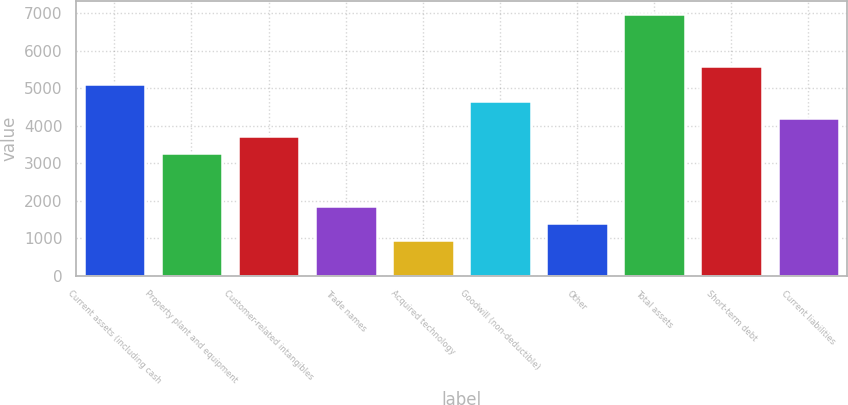<chart> <loc_0><loc_0><loc_500><loc_500><bar_chart><fcel>Current assets (including cash<fcel>Property plant and equipment<fcel>Customer-related intangibles<fcel>Trade names<fcel>Acquired technology<fcel>Goodwill (non-deductible)<fcel>Other<fcel>Total assets<fcel>Short-term debt<fcel>Current liabilities<nl><fcel>5123.9<fcel>3264.3<fcel>3729.2<fcel>1869.6<fcel>939.8<fcel>4659<fcel>1404.7<fcel>6983.5<fcel>5588.8<fcel>4194.1<nl></chart> 